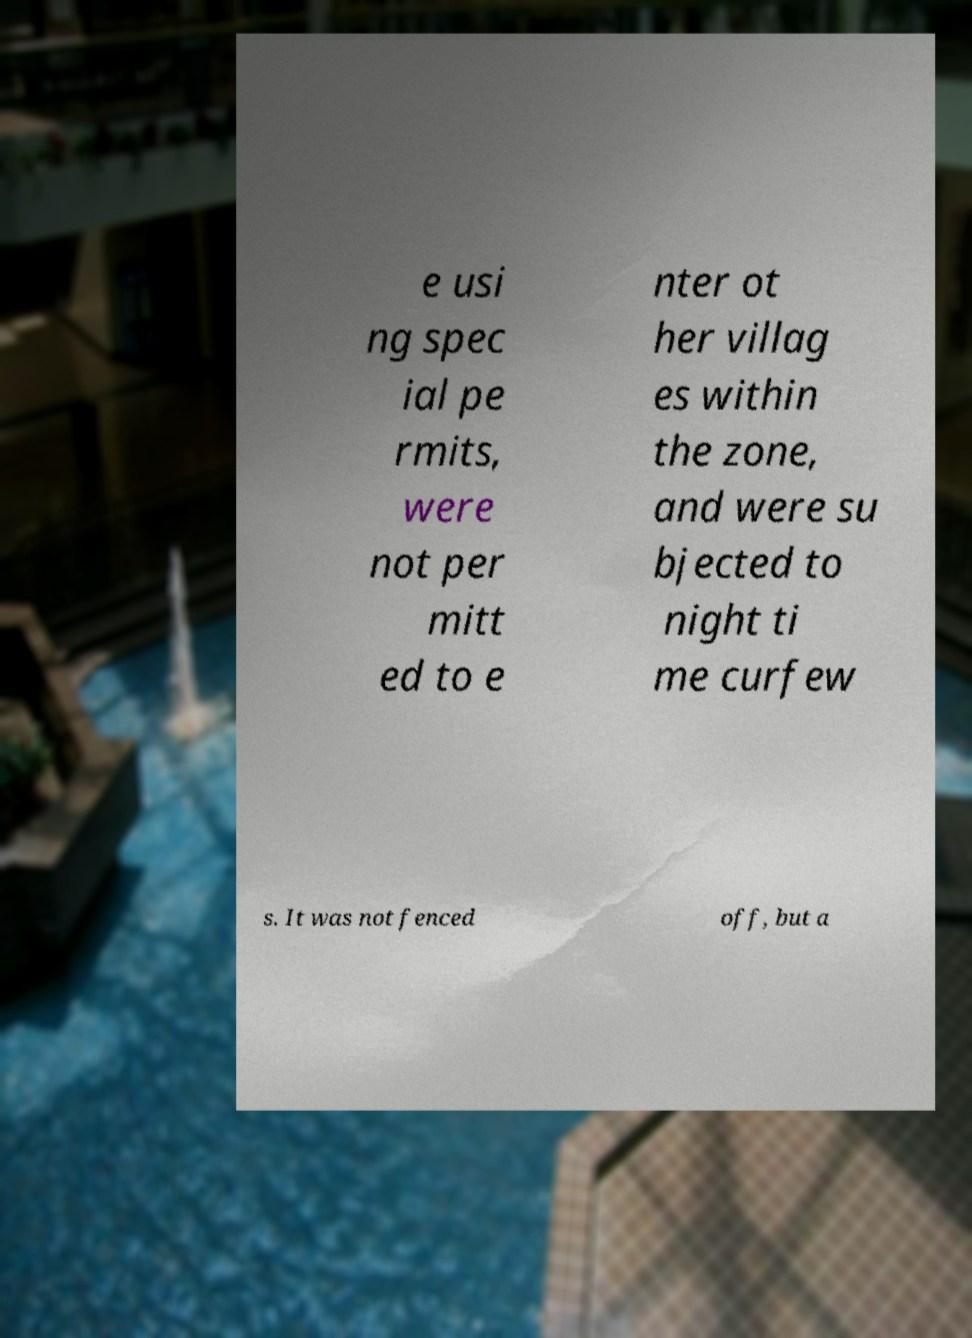Can you read and provide the text displayed in the image?This photo seems to have some interesting text. Can you extract and type it out for me? e usi ng spec ial pe rmits, were not per mitt ed to e nter ot her villag es within the zone, and were su bjected to night ti me curfew s. It was not fenced off, but a 